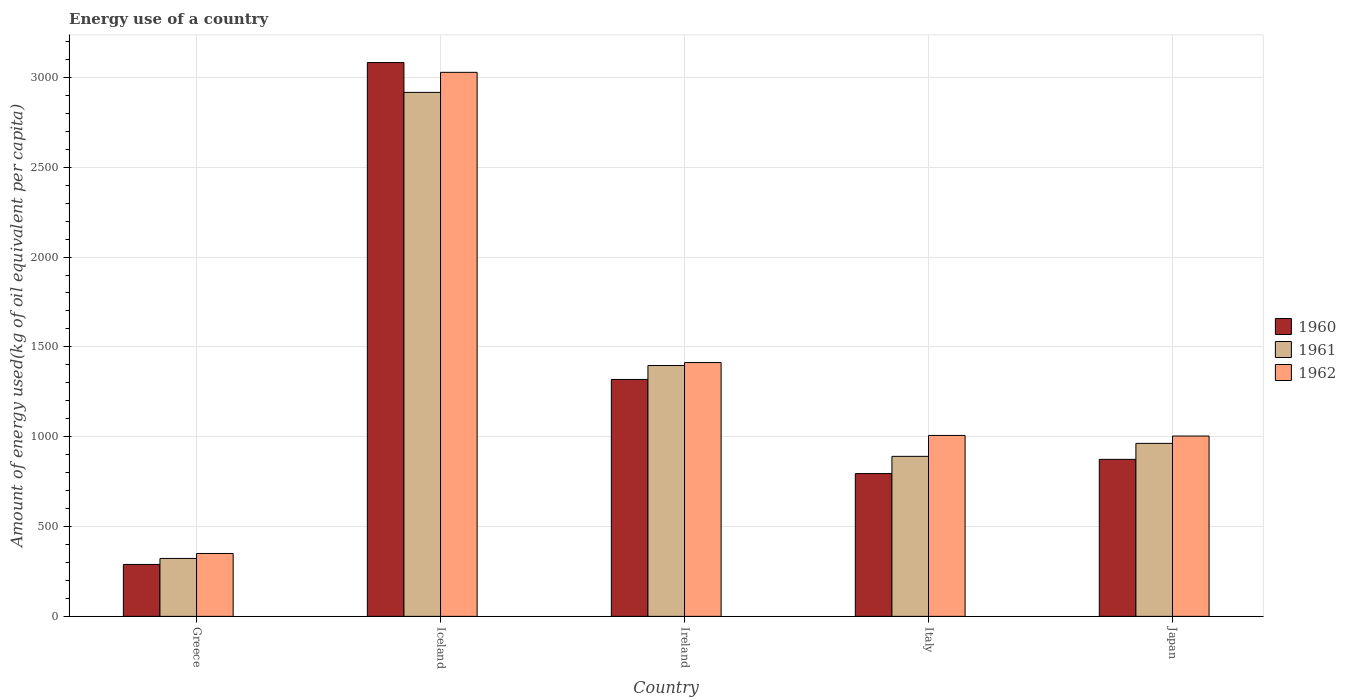How many different coloured bars are there?
Give a very brief answer. 3. How many bars are there on the 2nd tick from the right?
Ensure brevity in your answer.  3. In how many cases, is the number of bars for a given country not equal to the number of legend labels?
Provide a succinct answer. 0. What is the amount of energy used in in 1960 in Greece?
Offer a very short reply. 289.06. Across all countries, what is the maximum amount of energy used in in 1962?
Keep it short and to the point. 3028.3. Across all countries, what is the minimum amount of energy used in in 1960?
Offer a terse response. 289.06. What is the total amount of energy used in in 1962 in the graph?
Make the answer very short. 6801.93. What is the difference between the amount of energy used in in 1962 in Greece and that in Ireland?
Provide a short and direct response. -1062.63. What is the difference between the amount of energy used in in 1960 in Ireland and the amount of energy used in in 1962 in Italy?
Make the answer very short. 311.76. What is the average amount of energy used in in 1960 per country?
Offer a terse response. 1271.86. What is the difference between the amount of energy used in of/in 1962 and amount of energy used in of/in 1960 in Japan?
Give a very brief answer. 129.84. What is the ratio of the amount of energy used in in 1962 in Ireland to that in Italy?
Provide a short and direct response. 1.4. Is the difference between the amount of energy used in in 1962 in Greece and Japan greater than the difference between the amount of energy used in in 1960 in Greece and Japan?
Give a very brief answer. No. What is the difference between the highest and the second highest amount of energy used in in 1960?
Your answer should be compact. -2208.8. What is the difference between the highest and the lowest amount of energy used in in 1962?
Provide a succinct answer. 2678.2. Is the sum of the amount of energy used in in 1960 in Greece and Italy greater than the maximum amount of energy used in in 1961 across all countries?
Ensure brevity in your answer.  No. What does the 3rd bar from the left in Italy represents?
Your answer should be very brief. 1962. Is it the case that in every country, the sum of the amount of energy used in in 1962 and amount of energy used in in 1960 is greater than the amount of energy used in in 1961?
Make the answer very short. Yes. Are the values on the major ticks of Y-axis written in scientific E-notation?
Offer a terse response. No. Does the graph contain any zero values?
Give a very brief answer. No. Where does the legend appear in the graph?
Offer a terse response. Center right. How are the legend labels stacked?
Provide a succinct answer. Vertical. What is the title of the graph?
Offer a terse response. Energy use of a country. Does "1962" appear as one of the legend labels in the graph?
Make the answer very short. Yes. What is the label or title of the X-axis?
Your answer should be very brief. Country. What is the label or title of the Y-axis?
Provide a short and direct response. Amount of energy used(kg of oil equivalent per capita). What is the Amount of energy used(kg of oil equivalent per capita) in 1960 in Greece?
Offer a terse response. 289.06. What is the Amount of energy used(kg of oil equivalent per capita) in 1961 in Greece?
Provide a short and direct response. 322.49. What is the Amount of energy used(kg of oil equivalent per capita) of 1962 in Greece?
Offer a terse response. 350.1. What is the Amount of energy used(kg of oil equivalent per capita) of 1960 in Iceland?
Provide a succinct answer. 3082.71. What is the Amount of energy used(kg of oil equivalent per capita) of 1961 in Iceland?
Make the answer very short. 2916.71. What is the Amount of energy used(kg of oil equivalent per capita) of 1962 in Iceland?
Provide a short and direct response. 3028.3. What is the Amount of energy used(kg of oil equivalent per capita) in 1960 in Ireland?
Make the answer very short. 1318.81. What is the Amount of energy used(kg of oil equivalent per capita) in 1961 in Ireland?
Offer a very short reply. 1396.47. What is the Amount of energy used(kg of oil equivalent per capita) of 1962 in Ireland?
Provide a succinct answer. 1412.73. What is the Amount of energy used(kg of oil equivalent per capita) in 1960 in Italy?
Offer a terse response. 794.82. What is the Amount of energy used(kg of oil equivalent per capita) of 1961 in Italy?
Make the answer very short. 890.69. What is the Amount of energy used(kg of oil equivalent per capita) in 1962 in Italy?
Offer a terse response. 1007.05. What is the Amount of energy used(kg of oil equivalent per capita) of 1960 in Japan?
Give a very brief answer. 873.91. What is the Amount of energy used(kg of oil equivalent per capita) of 1961 in Japan?
Give a very brief answer. 962.91. What is the Amount of energy used(kg of oil equivalent per capita) in 1962 in Japan?
Keep it short and to the point. 1003.75. Across all countries, what is the maximum Amount of energy used(kg of oil equivalent per capita) of 1960?
Give a very brief answer. 3082.71. Across all countries, what is the maximum Amount of energy used(kg of oil equivalent per capita) in 1961?
Ensure brevity in your answer.  2916.71. Across all countries, what is the maximum Amount of energy used(kg of oil equivalent per capita) of 1962?
Offer a terse response. 3028.3. Across all countries, what is the minimum Amount of energy used(kg of oil equivalent per capita) in 1960?
Provide a succinct answer. 289.06. Across all countries, what is the minimum Amount of energy used(kg of oil equivalent per capita) of 1961?
Your answer should be very brief. 322.49. Across all countries, what is the minimum Amount of energy used(kg of oil equivalent per capita) of 1962?
Provide a short and direct response. 350.1. What is the total Amount of energy used(kg of oil equivalent per capita) in 1960 in the graph?
Make the answer very short. 6359.31. What is the total Amount of energy used(kg of oil equivalent per capita) in 1961 in the graph?
Your answer should be compact. 6489.26. What is the total Amount of energy used(kg of oil equivalent per capita) of 1962 in the graph?
Provide a succinct answer. 6801.93. What is the difference between the Amount of energy used(kg of oil equivalent per capita) in 1960 in Greece and that in Iceland?
Your answer should be compact. -2793.65. What is the difference between the Amount of energy used(kg of oil equivalent per capita) in 1961 in Greece and that in Iceland?
Keep it short and to the point. -2594.22. What is the difference between the Amount of energy used(kg of oil equivalent per capita) in 1962 in Greece and that in Iceland?
Offer a very short reply. -2678.2. What is the difference between the Amount of energy used(kg of oil equivalent per capita) of 1960 in Greece and that in Ireland?
Keep it short and to the point. -1029.76. What is the difference between the Amount of energy used(kg of oil equivalent per capita) of 1961 in Greece and that in Ireland?
Provide a succinct answer. -1073.98. What is the difference between the Amount of energy used(kg of oil equivalent per capita) of 1962 in Greece and that in Ireland?
Your response must be concise. -1062.63. What is the difference between the Amount of energy used(kg of oil equivalent per capita) of 1960 in Greece and that in Italy?
Provide a short and direct response. -505.76. What is the difference between the Amount of energy used(kg of oil equivalent per capita) of 1961 in Greece and that in Italy?
Offer a very short reply. -568.2. What is the difference between the Amount of energy used(kg of oil equivalent per capita) in 1962 in Greece and that in Italy?
Offer a very short reply. -656.95. What is the difference between the Amount of energy used(kg of oil equivalent per capita) of 1960 in Greece and that in Japan?
Make the answer very short. -584.85. What is the difference between the Amount of energy used(kg of oil equivalent per capita) of 1961 in Greece and that in Japan?
Your response must be concise. -640.42. What is the difference between the Amount of energy used(kg of oil equivalent per capita) in 1962 in Greece and that in Japan?
Provide a succinct answer. -653.65. What is the difference between the Amount of energy used(kg of oil equivalent per capita) in 1960 in Iceland and that in Ireland?
Your answer should be compact. 1763.9. What is the difference between the Amount of energy used(kg of oil equivalent per capita) of 1961 in Iceland and that in Ireland?
Your answer should be compact. 1520.24. What is the difference between the Amount of energy used(kg of oil equivalent per capita) in 1962 in Iceland and that in Ireland?
Provide a short and direct response. 1615.57. What is the difference between the Amount of energy used(kg of oil equivalent per capita) of 1960 in Iceland and that in Italy?
Offer a terse response. 2287.9. What is the difference between the Amount of energy used(kg of oil equivalent per capita) in 1961 in Iceland and that in Italy?
Provide a short and direct response. 2026.02. What is the difference between the Amount of energy used(kg of oil equivalent per capita) of 1962 in Iceland and that in Italy?
Your response must be concise. 2021.25. What is the difference between the Amount of energy used(kg of oil equivalent per capita) in 1960 in Iceland and that in Japan?
Your response must be concise. 2208.8. What is the difference between the Amount of energy used(kg of oil equivalent per capita) of 1961 in Iceland and that in Japan?
Your answer should be very brief. 1953.8. What is the difference between the Amount of energy used(kg of oil equivalent per capita) of 1962 in Iceland and that in Japan?
Keep it short and to the point. 2024.55. What is the difference between the Amount of energy used(kg of oil equivalent per capita) in 1960 in Ireland and that in Italy?
Give a very brief answer. 524. What is the difference between the Amount of energy used(kg of oil equivalent per capita) of 1961 in Ireland and that in Italy?
Make the answer very short. 505.78. What is the difference between the Amount of energy used(kg of oil equivalent per capita) of 1962 in Ireland and that in Italy?
Make the answer very short. 405.68. What is the difference between the Amount of energy used(kg of oil equivalent per capita) of 1960 in Ireland and that in Japan?
Offer a terse response. 444.9. What is the difference between the Amount of energy used(kg of oil equivalent per capita) in 1961 in Ireland and that in Japan?
Your answer should be very brief. 433.56. What is the difference between the Amount of energy used(kg of oil equivalent per capita) in 1962 in Ireland and that in Japan?
Provide a short and direct response. 408.98. What is the difference between the Amount of energy used(kg of oil equivalent per capita) in 1960 in Italy and that in Japan?
Keep it short and to the point. -79.09. What is the difference between the Amount of energy used(kg of oil equivalent per capita) in 1961 in Italy and that in Japan?
Your answer should be very brief. -72.22. What is the difference between the Amount of energy used(kg of oil equivalent per capita) of 1962 in Italy and that in Japan?
Keep it short and to the point. 3.3. What is the difference between the Amount of energy used(kg of oil equivalent per capita) in 1960 in Greece and the Amount of energy used(kg of oil equivalent per capita) in 1961 in Iceland?
Your answer should be very brief. -2627.65. What is the difference between the Amount of energy used(kg of oil equivalent per capita) of 1960 in Greece and the Amount of energy used(kg of oil equivalent per capita) of 1962 in Iceland?
Provide a short and direct response. -2739.24. What is the difference between the Amount of energy used(kg of oil equivalent per capita) in 1961 in Greece and the Amount of energy used(kg of oil equivalent per capita) in 1962 in Iceland?
Provide a short and direct response. -2705.81. What is the difference between the Amount of energy used(kg of oil equivalent per capita) of 1960 in Greece and the Amount of energy used(kg of oil equivalent per capita) of 1961 in Ireland?
Keep it short and to the point. -1107.41. What is the difference between the Amount of energy used(kg of oil equivalent per capita) in 1960 in Greece and the Amount of energy used(kg of oil equivalent per capita) in 1962 in Ireland?
Offer a terse response. -1123.67. What is the difference between the Amount of energy used(kg of oil equivalent per capita) of 1961 in Greece and the Amount of energy used(kg of oil equivalent per capita) of 1962 in Ireland?
Ensure brevity in your answer.  -1090.24. What is the difference between the Amount of energy used(kg of oil equivalent per capita) in 1960 in Greece and the Amount of energy used(kg of oil equivalent per capita) in 1961 in Italy?
Provide a short and direct response. -601.63. What is the difference between the Amount of energy used(kg of oil equivalent per capita) of 1960 in Greece and the Amount of energy used(kg of oil equivalent per capita) of 1962 in Italy?
Ensure brevity in your answer.  -717.99. What is the difference between the Amount of energy used(kg of oil equivalent per capita) of 1961 in Greece and the Amount of energy used(kg of oil equivalent per capita) of 1962 in Italy?
Offer a very short reply. -684.56. What is the difference between the Amount of energy used(kg of oil equivalent per capita) of 1960 in Greece and the Amount of energy used(kg of oil equivalent per capita) of 1961 in Japan?
Offer a very short reply. -673.85. What is the difference between the Amount of energy used(kg of oil equivalent per capita) of 1960 in Greece and the Amount of energy used(kg of oil equivalent per capita) of 1962 in Japan?
Offer a terse response. -714.7. What is the difference between the Amount of energy used(kg of oil equivalent per capita) of 1961 in Greece and the Amount of energy used(kg of oil equivalent per capita) of 1962 in Japan?
Offer a very short reply. -681.26. What is the difference between the Amount of energy used(kg of oil equivalent per capita) of 1960 in Iceland and the Amount of energy used(kg of oil equivalent per capita) of 1961 in Ireland?
Offer a very short reply. 1686.25. What is the difference between the Amount of energy used(kg of oil equivalent per capita) of 1960 in Iceland and the Amount of energy used(kg of oil equivalent per capita) of 1962 in Ireland?
Offer a terse response. 1669.98. What is the difference between the Amount of energy used(kg of oil equivalent per capita) of 1961 in Iceland and the Amount of energy used(kg of oil equivalent per capita) of 1962 in Ireland?
Provide a succinct answer. 1503.98. What is the difference between the Amount of energy used(kg of oil equivalent per capita) of 1960 in Iceland and the Amount of energy used(kg of oil equivalent per capita) of 1961 in Italy?
Your answer should be very brief. 2192.02. What is the difference between the Amount of energy used(kg of oil equivalent per capita) of 1960 in Iceland and the Amount of energy used(kg of oil equivalent per capita) of 1962 in Italy?
Offer a very short reply. 2075.66. What is the difference between the Amount of energy used(kg of oil equivalent per capita) in 1961 in Iceland and the Amount of energy used(kg of oil equivalent per capita) in 1962 in Italy?
Provide a short and direct response. 1909.66. What is the difference between the Amount of energy used(kg of oil equivalent per capita) of 1960 in Iceland and the Amount of energy used(kg of oil equivalent per capita) of 1961 in Japan?
Your response must be concise. 2119.8. What is the difference between the Amount of energy used(kg of oil equivalent per capita) in 1960 in Iceland and the Amount of energy used(kg of oil equivalent per capita) in 1962 in Japan?
Ensure brevity in your answer.  2078.96. What is the difference between the Amount of energy used(kg of oil equivalent per capita) of 1961 in Iceland and the Amount of energy used(kg of oil equivalent per capita) of 1962 in Japan?
Your answer should be compact. 1912.95. What is the difference between the Amount of energy used(kg of oil equivalent per capita) in 1960 in Ireland and the Amount of energy used(kg of oil equivalent per capita) in 1961 in Italy?
Offer a very short reply. 428.12. What is the difference between the Amount of energy used(kg of oil equivalent per capita) of 1960 in Ireland and the Amount of energy used(kg of oil equivalent per capita) of 1962 in Italy?
Provide a short and direct response. 311.76. What is the difference between the Amount of energy used(kg of oil equivalent per capita) of 1961 in Ireland and the Amount of energy used(kg of oil equivalent per capita) of 1962 in Italy?
Offer a terse response. 389.42. What is the difference between the Amount of energy used(kg of oil equivalent per capita) in 1960 in Ireland and the Amount of energy used(kg of oil equivalent per capita) in 1961 in Japan?
Offer a terse response. 355.91. What is the difference between the Amount of energy used(kg of oil equivalent per capita) in 1960 in Ireland and the Amount of energy used(kg of oil equivalent per capita) in 1962 in Japan?
Your response must be concise. 315.06. What is the difference between the Amount of energy used(kg of oil equivalent per capita) in 1961 in Ireland and the Amount of energy used(kg of oil equivalent per capita) in 1962 in Japan?
Provide a succinct answer. 392.71. What is the difference between the Amount of energy used(kg of oil equivalent per capita) in 1960 in Italy and the Amount of energy used(kg of oil equivalent per capita) in 1961 in Japan?
Ensure brevity in your answer.  -168.09. What is the difference between the Amount of energy used(kg of oil equivalent per capita) in 1960 in Italy and the Amount of energy used(kg of oil equivalent per capita) in 1962 in Japan?
Make the answer very short. -208.94. What is the difference between the Amount of energy used(kg of oil equivalent per capita) of 1961 in Italy and the Amount of energy used(kg of oil equivalent per capita) of 1962 in Japan?
Offer a very short reply. -113.06. What is the average Amount of energy used(kg of oil equivalent per capita) of 1960 per country?
Offer a terse response. 1271.86. What is the average Amount of energy used(kg of oil equivalent per capita) in 1961 per country?
Provide a short and direct response. 1297.85. What is the average Amount of energy used(kg of oil equivalent per capita) in 1962 per country?
Keep it short and to the point. 1360.39. What is the difference between the Amount of energy used(kg of oil equivalent per capita) in 1960 and Amount of energy used(kg of oil equivalent per capita) in 1961 in Greece?
Keep it short and to the point. -33.43. What is the difference between the Amount of energy used(kg of oil equivalent per capita) in 1960 and Amount of energy used(kg of oil equivalent per capita) in 1962 in Greece?
Your answer should be very brief. -61.04. What is the difference between the Amount of energy used(kg of oil equivalent per capita) of 1961 and Amount of energy used(kg of oil equivalent per capita) of 1962 in Greece?
Give a very brief answer. -27.61. What is the difference between the Amount of energy used(kg of oil equivalent per capita) of 1960 and Amount of energy used(kg of oil equivalent per capita) of 1961 in Iceland?
Offer a terse response. 166.01. What is the difference between the Amount of energy used(kg of oil equivalent per capita) of 1960 and Amount of energy used(kg of oil equivalent per capita) of 1962 in Iceland?
Provide a succinct answer. 54.41. What is the difference between the Amount of energy used(kg of oil equivalent per capita) of 1961 and Amount of energy used(kg of oil equivalent per capita) of 1962 in Iceland?
Give a very brief answer. -111.59. What is the difference between the Amount of energy used(kg of oil equivalent per capita) of 1960 and Amount of energy used(kg of oil equivalent per capita) of 1961 in Ireland?
Provide a short and direct response. -77.65. What is the difference between the Amount of energy used(kg of oil equivalent per capita) in 1960 and Amount of energy used(kg of oil equivalent per capita) in 1962 in Ireland?
Offer a very short reply. -93.92. What is the difference between the Amount of energy used(kg of oil equivalent per capita) in 1961 and Amount of energy used(kg of oil equivalent per capita) in 1962 in Ireland?
Give a very brief answer. -16.26. What is the difference between the Amount of energy used(kg of oil equivalent per capita) of 1960 and Amount of energy used(kg of oil equivalent per capita) of 1961 in Italy?
Offer a terse response. -95.87. What is the difference between the Amount of energy used(kg of oil equivalent per capita) in 1960 and Amount of energy used(kg of oil equivalent per capita) in 1962 in Italy?
Ensure brevity in your answer.  -212.23. What is the difference between the Amount of energy used(kg of oil equivalent per capita) of 1961 and Amount of energy used(kg of oil equivalent per capita) of 1962 in Italy?
Give a very brief answer. -116.36. What is the difference between the Amount of energy used(kg of oil equivalent per capita) in 1960 and Amount of energy used(kg of oil equivalent per capita) in 1961 in Japan?
Provide a succinct answer. -89. What is the difference between the Amount of energy used(kg of oil equivalent per capita) of 1960 and Amount of energy used(kg of oil equivalent per capita) of 1962 in Japan?
Keep it short and to the point. -129.84. What is the difference between the Amount of energy used(kg of oil equivalent per capita) of 1961 and Amount of energy used(kg of oil equivalent per capita) of 1962 in Japan?
Ensure brevity in your answer.  -40.85. What is the ratio of the Amount of energy used(kg of oil equivalent per capita) of 1960 in Greece to that in Iceland?
Make the answer very short. 0.09. What is the ratio of the Amount of energy used(kg of oil equivalent per capita) in 1961 in Greece to that in Iceland?
Ensure brevity in your answer.  0.11. What is the ratio of the Amount of energy used(kg of oil equivalent per capita) in 1962 in Greece to that in Iceland?
Provide a succinct answer. 0.12. What is the ratio of the Amount of energy used(kg of oil equivalent per capita) in 1960 in Greece to that in Ireland?
Give a very brief answer. 0.22. What is the ratio of the Amount of energy used(kg of oil equivalent per capita) of 1961 in Greece to that in Ireland?
Provide a succinct answer. 0.23. What is the ratio of the Amount of energy used(kg of oil equivalent per capita) in 1962 in Greece to that in Ireland?
Offer a very short reply. 0.25. What is the ratio of the Amount of energy used(kg of oil equivalent per capita) in 1960 in Greece to that in Italy?
Provide a short and direct response. 0.36. What is the ratio of the Amount of energy used(kg of oil equivalent per capita) in 1961 in Greece to that in Italy?
Give a very brief answer. 0.36. What is the ratio of the Amount of energy used(kg of oil equivalent per capita) in 1962 in Greece to that in Italy?
Offer a very short reply. 0.35. What is the ratio of the Amount of energy used(kg of oil equivalent per capita) of 1960 in Greece to that in Japan?
Your answer should be very brief. 0.33. What is the ratio of the Amount of energy used(kg of oil equivalent per capita) in 1961 in Greece to that in Japan?
Your answer should be very brief. 0.33. What is the ratio of the Amount of energy used(kg of oil equivalent per capita) in 1962 in Greece to that in Japan?
Keep it short and to the point. 0.35. What is the ratio of the Amount of energy used(kg of oil equivalent per capita) in 1960 in Iceland to that in Ireland?
Your response must be concise. 2.34. What is the ratio of the Amount of energy used(kg of oil equivalent per capita) of 1961 in Iceland to that in Ireland?
Make the answer very short. 2.09. What is the ratio of the Amount of energy used(kg of oil equivalent per capita) in 1962 in Iceland to that in Ireland?
Offer a terse response. 2.14. What is the ratio of the Amount of energy used(kg of oil equivalent per capita) in 1960 in Iceland to that in Italy?
Give a very brief answer. 3.88. What is the ratio of the Amount of energy used(kg of oil equivalent per capita) of 1961 in Iceland to that in Italy?
Offer a very short reply. 3.27. What is the ratio of the Amount of energy used(kg of oil equivalent per capita) in 1962 in Iceland to that in Italy?
Provide a short and direct response. 3.01. What is the ratio of the Amount of energy used(kg of oil equivalent per capita) in 1960 in Iceland to that in Japan?
Ensure brevity in your answer.  3.53. What is the ratio of the Amount of energy used(kg of oil equivalent per capita) of 1961 in Iceland to that in Japan?
Keep it short and to the point. 3.03. What is the ratio of the Amount of energy used(kg of oil equivalent per capita) of 1962 in Iceland to that in Japan?
Your response must be concise. 3.02. What is the ratio of the Amount of energy used(kg of oil equivalent per capita) of 1960 in Ireland to that in Italy?
Provide a short and direct response. 1.66. What is the ratio of the Amount of energy used(kg of oil equivalent per capita) of 1961 in Ireland to that in Italy?
Provide a succinct answer. 1.57. What is the ratio of the Amount of energy used(kg of oil equivalent per capita) in 1962 in Ireland to that in Italy?
Keep it short and to the point. 1.4. What is the ratio of the Amount of energy used(kg of oil equivalent per capita) in 1960 in Ireland to that in Japan?
Keep it short and to the point. 1.51. What is the ratio of the Amount of energy used(kg of oil equivalent per capita) in 1961 in Ireland to that in Japan?
Your answer should be compact. 1.45. What is the ratio of the Amount of energy used(kg of oil equivalent per capita) in 1962 in Ireland to that in Japan?
Ensure brevity in your answer.  1.41. What is the ratio of the Amount of energy used(kg of oil equivalent per capita) in 1960 in Italy to that in Japan?
Make the answer very short. 0.91. What is the ratio of the Amount of energy used(kg of oil equivalent per capita) of 1961 in Italy to that in Japan?
Provide a short and direct response. 0.93. What is the ratio of the Amount of energy used(kg of oil equivalent per capita) of 1962 in Italy to that in Japan?
Your answer should be compact. 1. What is the difference between the highest and the second highest Amount of energy used(kg of oil equivalent per capita) of 1960?
Provide a succinct answer. 1763.9. What is the difference between the highest and the second highest Amount of energy used(kg of oil equivalent per capita) of 1961?
Ensure brevity in your answer.  1520.24. What is the difference between the highest and the second highest Amount of energy used(kg of oil equivalent per capita) in 1962?
Offer a terse response. 1615.57. What is the difference between the highest and the lowest Amount of energy used(kg of oil equivalent per capita) in 1960?
Provide a succinct answer. 2793.65. What is the difference between the highest and the lowest Amount of energy used(kg of oil equivalent per capita) in 1961?
Ensure brevity in your answer.  2594.22. What is the difference between the highest and the lowest Amount of energy used(kg of oil equivalent per capita) of 1962?
Make the answer very short. 2678.2. 